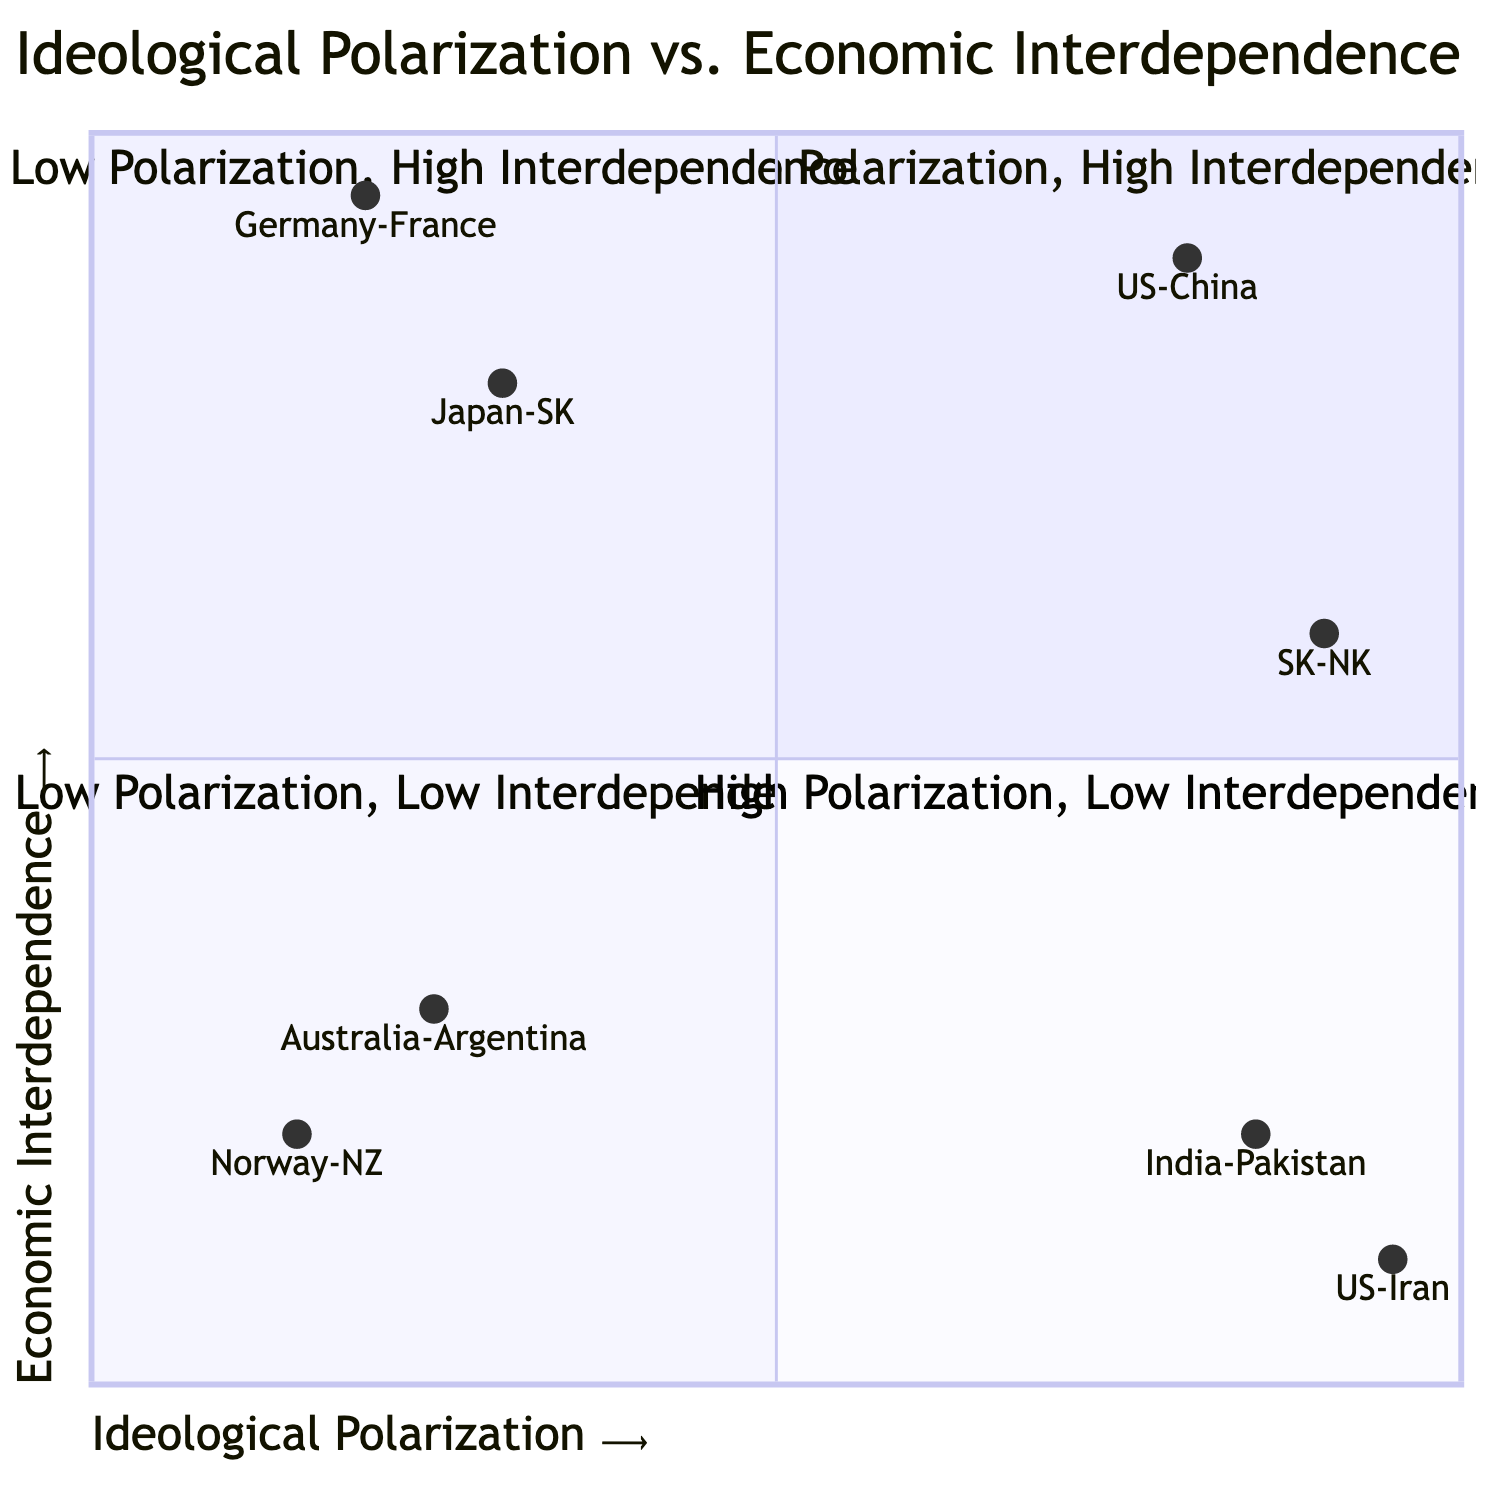What countries are in the High Polarization, High Interdependence quadrant? The High Polarization, High Interdependence quadrant includes the United States and China, and South Korea and North Korea.
Answer: United States and China; South Korea and North Korea Which country pair exhibits the highest ideological polarization? Reviewing the country pairs, the pair with the highest ideological polarization is the United States and Iran, with a score of 0.95.
Answer: United States and Iran What is the economic interdependence score for Germany and France? The diagram indicates that Germany and France have a high economic interdependence score of 0.95.
Answer: 0.95 How many country pairs are in the Low Polarization, Low Interdependence quadrant? There are two country pairs in this quadrant, which are Australia and Argentina, and Norway and New Zealand.
Answer: 2 Which quadrant contains the example of India and Pakistan? India and Pakistan are located in the High Polarization, Low Interdependence quadrant, characterized by ongoing conflict and trade restrictions.
Answer: High Polarization, Low Interdependence What is the economic interdependence score of the United States and China? The given data shows that the economic interdependence score for the United States and China is 0.9.
Answer: 0.9 Which country pair shows low ideological polarization but high economic interdependence? The country pairs that demonstrate low ideological polarization along with high economic interdependence are Germany and France, and Japan and South Korea.
Answer: Germany and France; Japan and South Korea What are the characteristics of countries in the Low Polarization, High Interdependence quadrant? Countries in the Low Polarization, High Interdependence quadrant, like Germany and France, have compatible ideologies and strong economic ties, especially within the EU.
Answer: Compatible ideologies; strong economic ties 